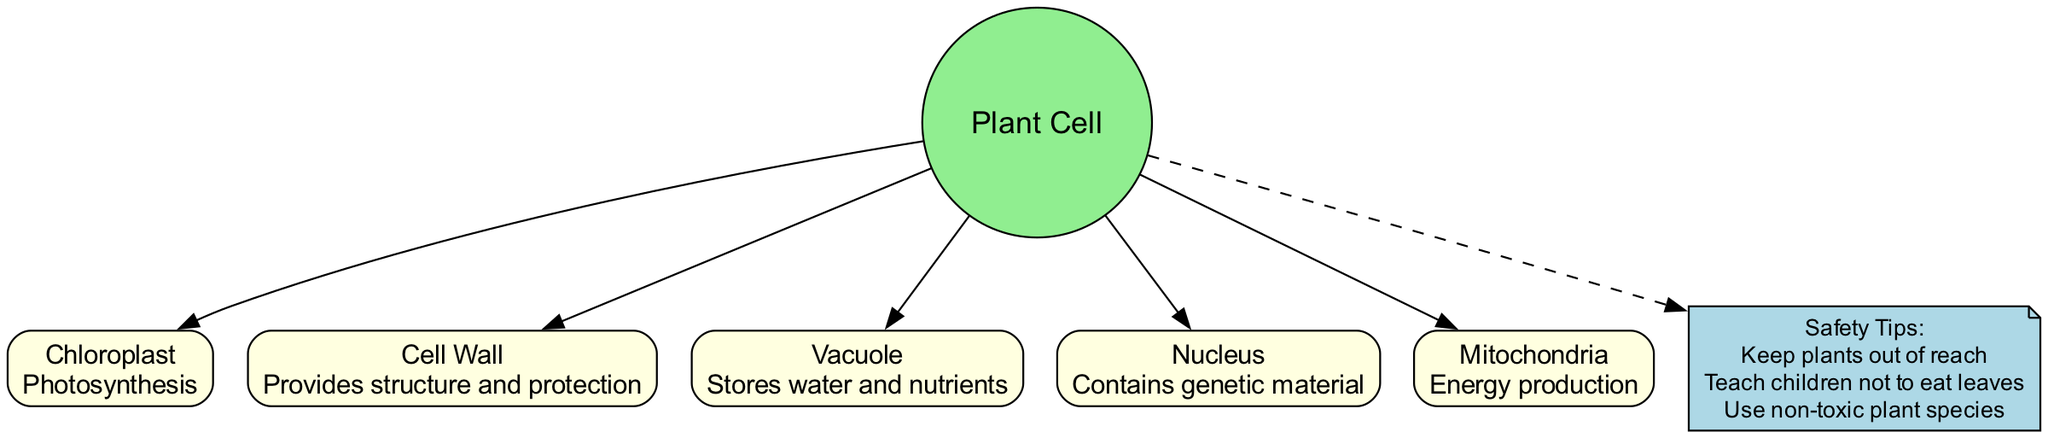What is the function of the Chloroplast? The diagram labels the Chloroplast with its function, which is "Photosynthesis". This information is displayed directly in the node associated with the Chloroplast.
Answer: Photosynthesis How many organelles are present in the diagram? The diagram includes five organelles listed under the central node of the Plant Cell. Counting the items in the organelles list confirms this quantity.
Answer: Five What does the Vacuole store? The Vacuole is labeled in the diagram with its primary function, which states it "Stores water and nutrients". This information is clearly presented in its corresponding node.
Answer: Water and nutrients What protective structure does the plant cell have? The Cell Wall is specifically mentioned in the diagram as providing "structure and protection", indicating its role in safeguarding the plant cell.
Answer: Cell Wall Which organelle is responsible for energy production? The node for Mitochondria in the diagram states its function as "Energy production". This identifies it as the organelle responsible for that activity.
Answer: Mitochondria How are safety tips related to the plant cell displayed in the diagram? The diagram connects safety tips to the central Plant Cell node with a dashed edge, indicating a relationship that highlights precautions regarding plant cells, especially for children. The safety tips mention keeping plants out of reach and using non-toxic species.
Answer: Safety Tips Which organelle contains genetic material? The diagram labels the Nucleus as the component that "Contains genetic material", indicating its essential role in housing DNA within the plant cell.
Answer: Nucleus What color is the central node representing the Plant Cell? The diagram uses light green filling for the circular central node that represents the Plant Cell, as indicated in the attributes set for that node.
Answer: Light green What is a suggested action to ensure children's safety around plants according to the diagram? The safety tips node outlines that "Teach children not to eat leaves" is one of the suggested actions, linking the importance of education to safety around plant cells.
Answer: Teach children not to eat leaves 